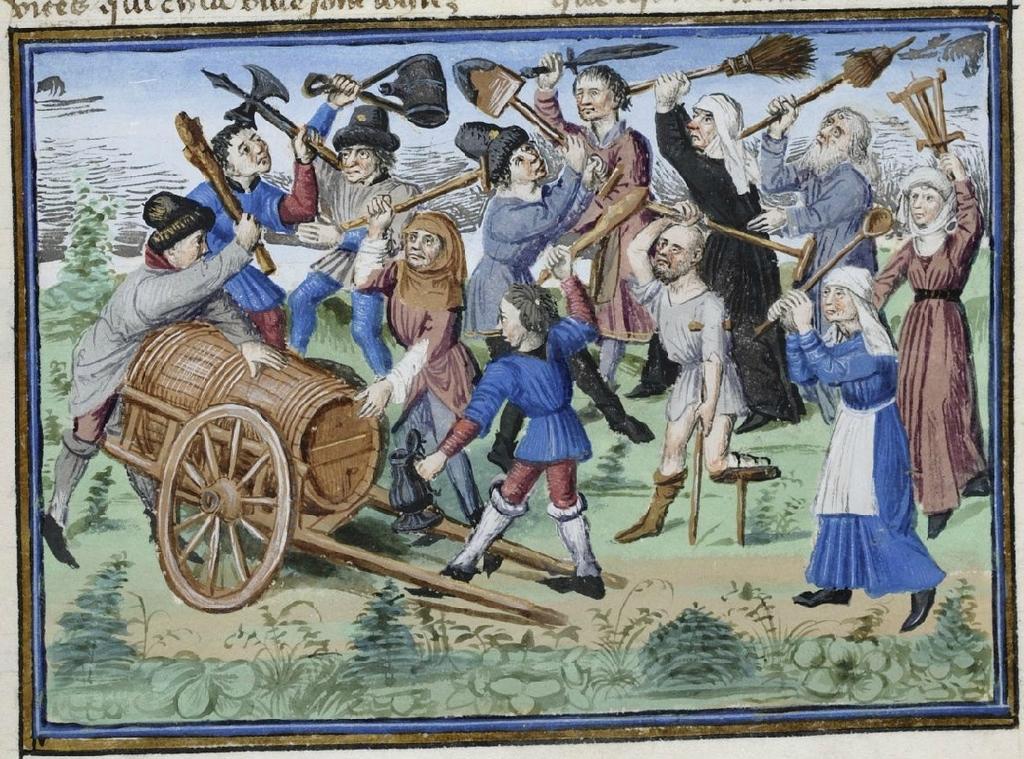How would you summarize this image in a sentence or two? In this picture there is a drawing poster. In the front there are many men and women, standing and holding a broomstick in the hand. On the left side there is a chariot. 